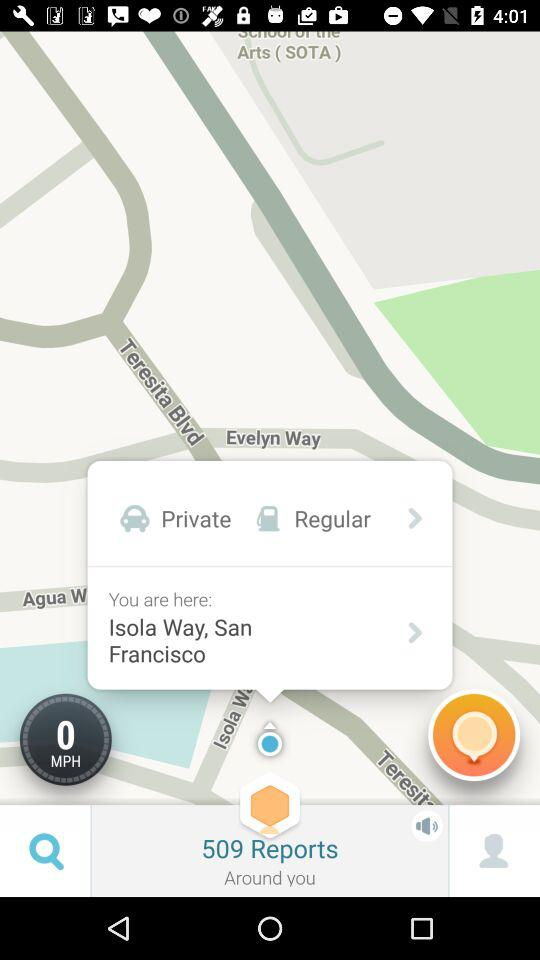What is the count of reports? The count of reports is 509. 